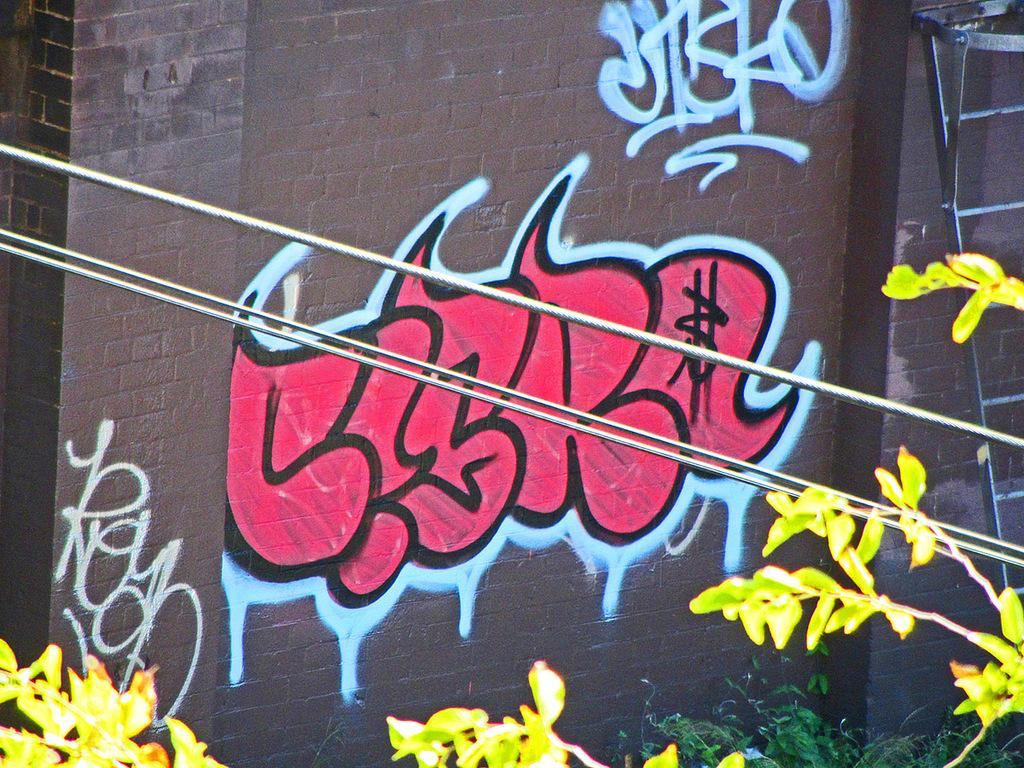What is depicted on the wall of the building in the image? There is graffiti on the wall of a building in the image. What else can be seen in the image besides the graffiti? There are plants and electrical wires in the image. Where is the island located in the image? There is no island present in the image. What type of spot can be seen on the plants in the image? There are no spots visible on the plants in the image. 